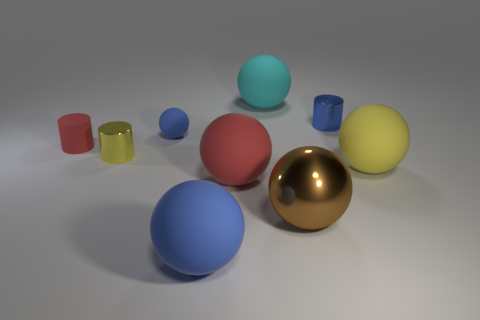Can you tell me more about the lighting in this scene? Certainly! The lighting in this 3D rendered scene appears to be soft and diffused, coming from a source above the arrangement of objects. Shadows are soft-edged, indicating the light source is not harsh. This mimics an overcast sky or a studio setting with a light diffuser, giving the image a calm and even tone.  What might be the purpose of creating an image like this? An image like this could serve multiple purposes. It could be used to demonstrate rendering techniques, material textures, and lighting effects in a 3D modeling software. It could also serve educational purposes for teaching digital art and design concepts, or it might be a part of a portfolio showcasing a 3D artist’s skills. 